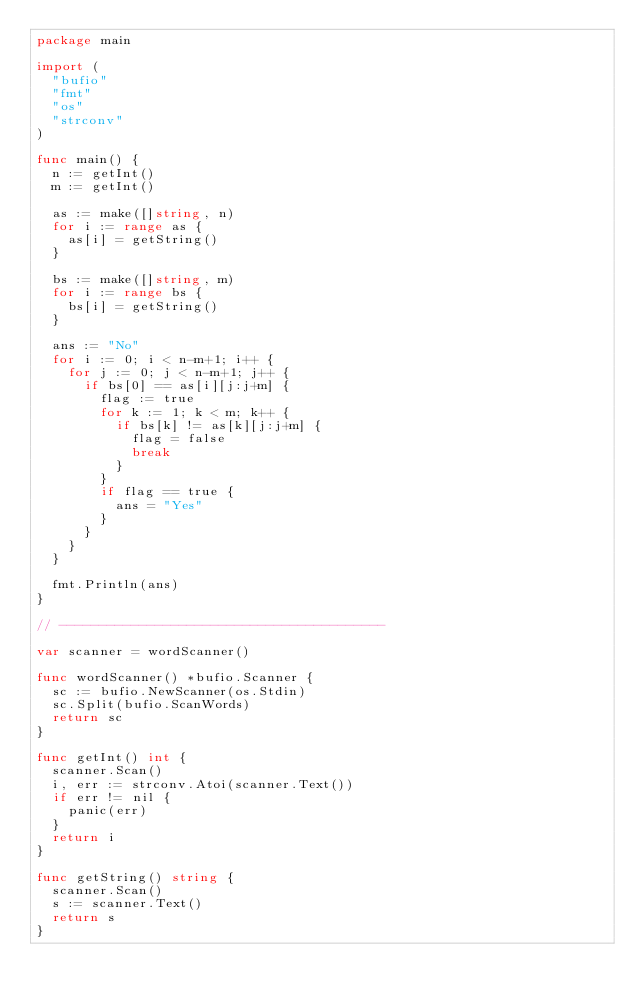<code> <loc_0><loc_0><loc_500><loc_500><_Go_>package main

import (
	"bufio"
	"fmt"
	"os"
	"strconv"
)

func main() {
	n := getInt()
	m := getInt()

	as := make([]string, n)
	for i := range as {
		as[i] = getString()
	}

	bs := make([]string, m)
	for i := range bs {
		bs[i] = getString()
	}

	ans := "No"
	for i := 0; i < n-m+1; i++ {
		for j := 0; j < n-m+1; j++ {
			if bs[0] == as[i][j:j+m] {
				flag := true
				for k := 1; k < m; k++ {
					if bs[k] != as[k][j:j+m] {
						flag = false
						break
					}
				}
				if flag == true {
					ans = "Yes"
				}
			}
		}
	}

	fmt.Println(ans)
}

// -----------------------------------------

var scanner = wordScanner()

func wordScanner() *bufio.Scanner {
	sc := bufio.NewScanner(os.Stdin)
	sc.Split(bufio.ScanWords)
	return sc
}

func getInt() int {
	scanner.Scan()
	i, err := strconv.Atoi(scanner.Text())
	if err != nil {
		panic(err)
	}
	return i
}

func getString() string {
	scanner.Scan()
	s := scanner.Text()
	return s
}
</code> 